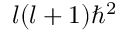<formula> <loc_0><loc_0><loc_500><loc_500>l ( l + 1 ) \hbar { ^ } { 2 }</formula> 